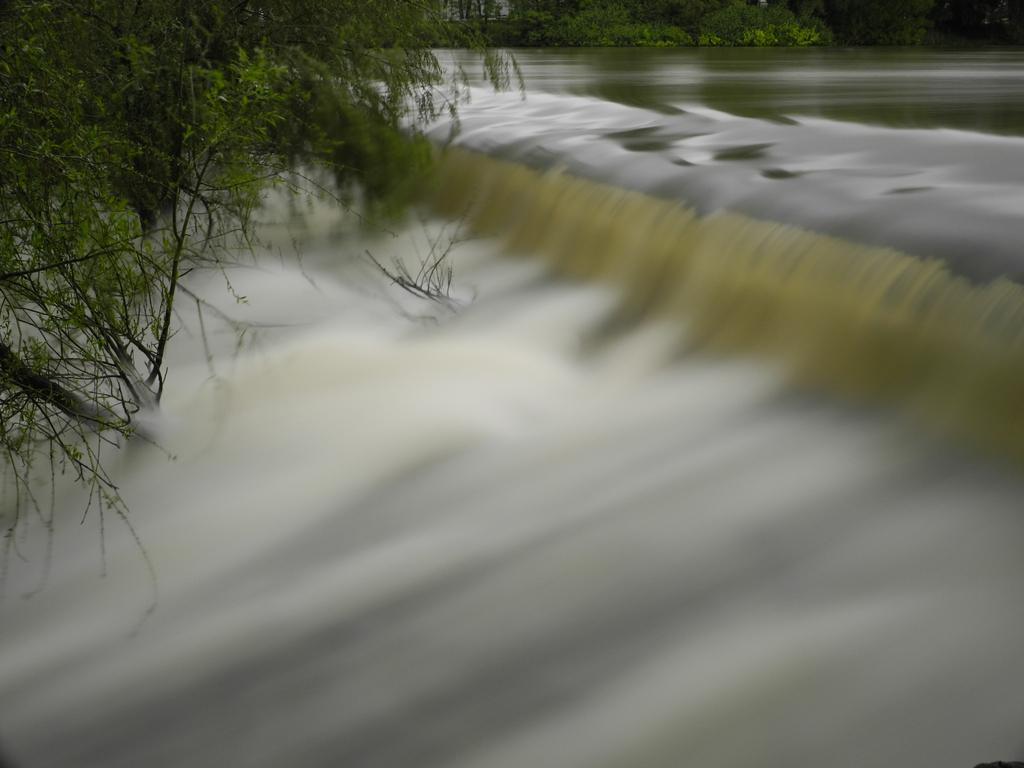What natural feature is the main subject of the picture? There is a waterfall in the picture. What type of vegetation can be seen in the picture? There are trees in the picture. What type of metal badge can be seen hanging from the waterfall in the image? There is no metal badge present in the image; it features a waterfall and trees. 